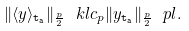<formula> <loc_0><loc_0><loc_500><loc_500>\| \langle y \rangle _ { \tt t _ { a } } \| _ { \frac { p } { 2 } } \ k l c _ { p } \| y _ { \tt t _ { a } } \| _ { \frac { p } { 2 } } \ p l .</formula> 